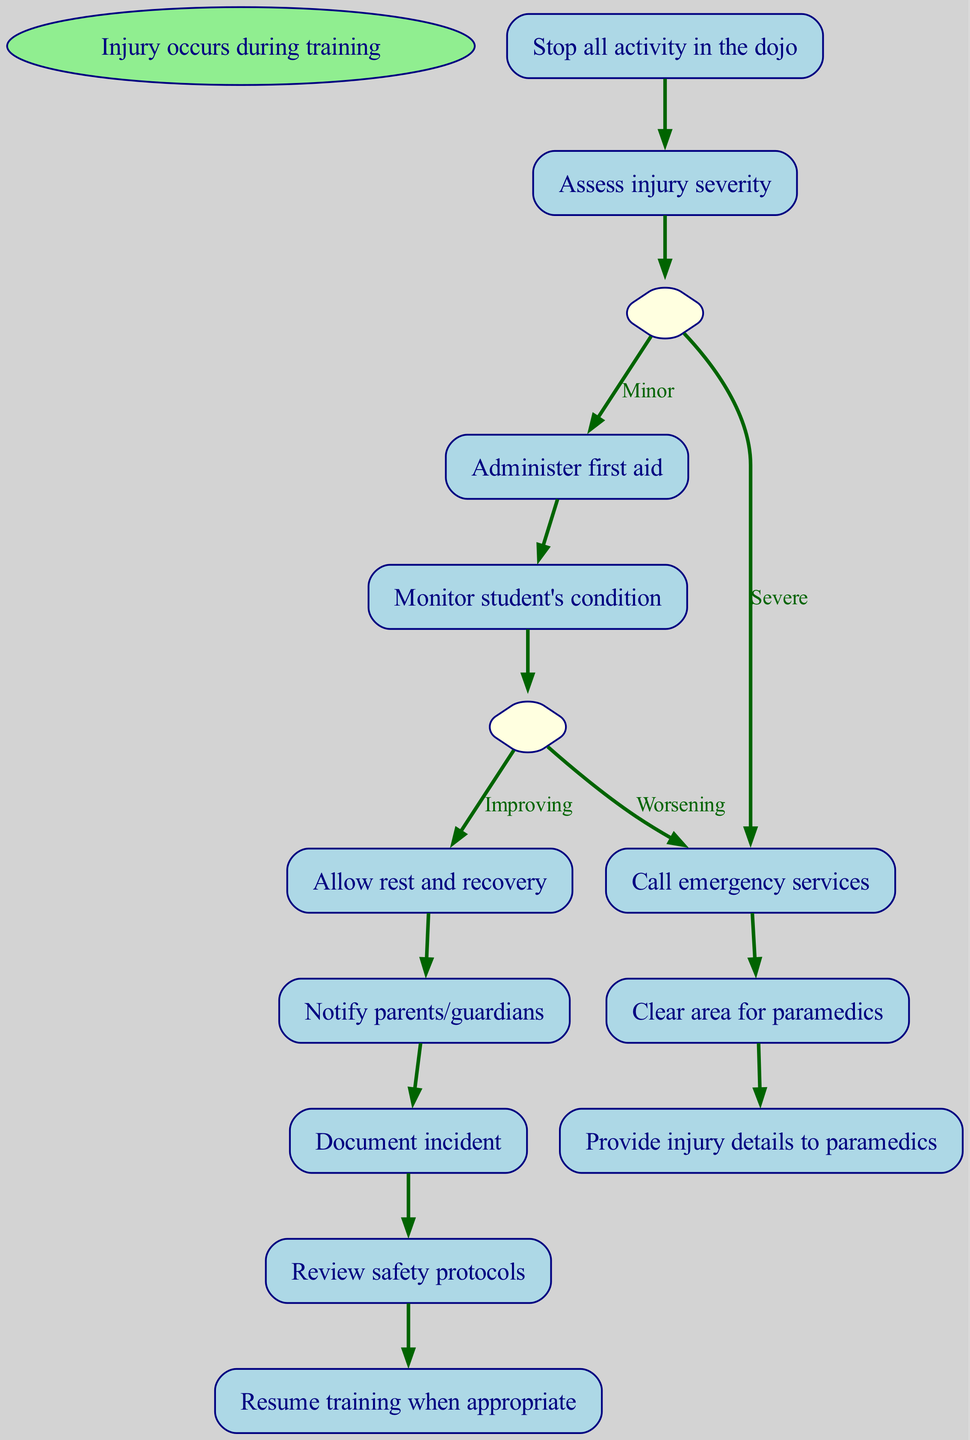What is the first action taken when an injury occurs? The flow chart indicates that the first action is to "Stop all activity in the dojo" as the process begins with the injury event.
Answer: Stop all activity in the dojo How many steps are there in total in the procedure? By counting the steps listed in the flow chart, including the start node, we find that there are a total of 10 steps in the procedure.
Answer: 10 What action follows "Administer first aid"? After "Administer first aid," the next action indicated is to "Monitor student's condition." This can be found directly connected in the flow chart.
Answer: Monitor student's condition If the injury is "Severe," what is the next step to be taken? According to the decision made at the "Assess injury severity" step, if the injury is deemed "Severe," the next step is to "Call emergency services." This connects directly from the decision node.
Answer: Call emergency services What happens if the student's condition is "Worsening"? In the diagram, if the condition "Worsening" occurs during "Monitor student's condition," the next action is to "Call emergency services." This indicates a critical response based on the condition assessed.
Answer: Call emergency services How do you document the injury incident? "Document incident" is a step that follows notifying parents/guardians in the procedure, indicating that this is where the official records of the incident are created.
Answer: Document incident What action must be taken after "Clear area for paramedics"? After the "Clear area for paramedics" step, the procedure instructs to "Provide injury details to paramedics," linking directly from one action to the other.
Answer: Provide injury details to paramedics What should be done once the student's condition is "Improving"? If the condition has improved, the chart instructs to "Allow rest and recovery," demonstrating a positive progression in the response protocol.
Answer: Allow rest and recovery What is the ultimate outcome after reviewing safety protocols? The last action listed after "Review safety protocols" is "Resume training when appropriate," indicating the end of the emergency response process as training can continue safely.
Answer: Resume training when appropriate 